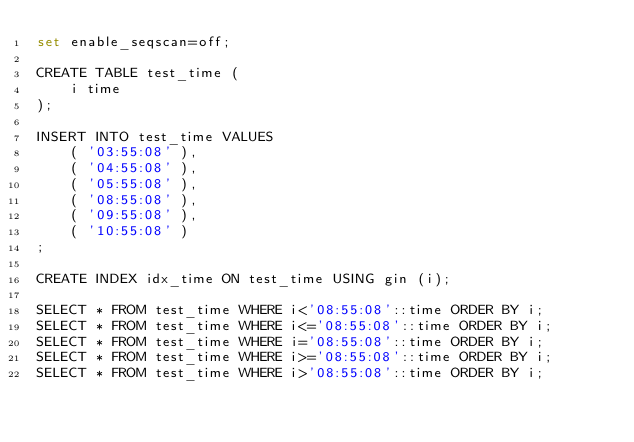<code> <loc_0><loc_0><loc_500><loc_500><_SQL_>set enable_seqscan=off;

CREATE TABLE test_time (
	i time
);

INSERT INTO test_time VALUES
	( '03:55:08' ),
	( '04:55:08' ),
	( '05:55:08' ),
	( '08:55:08' ),
	( '09:55:08' ),
	( '10:55:08' )
;

CREATE INDEX idx_time ON test_time USING gin (i);

SELECT * FROM test_time WHERE i<'08:55:08'::time ORDER BY i;
SELECT * FROM test_time WHERE i<='08:55:08'::time ORDER BY i;
SELECT * FROM test_time WHERE i='08:55:08'::time ORDER BY i;
SELECT * FROM test_time WHERE i>='08:55:08'::time ORDER BY i;
SELECT * FROM test_time WHERE i>'08:55:08'::time ORDER BY i;
</code> 